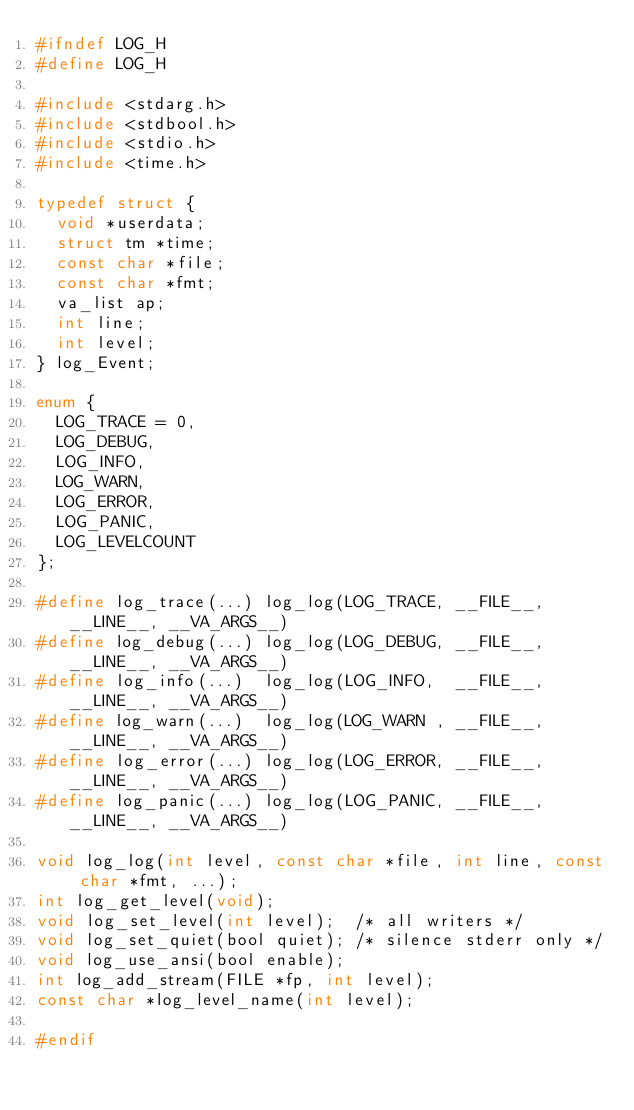Convert code to text. <code><loc_0><loc_0><loc_500><loc_500><_C_>#ifndef LOG_H
#define LOG_H

#include <stdarg.h>
#include <stdbool.h>
#include <stdio.h>
#include <time.h>

typedef struct {
  void *userdata;
  struct tm *time;
  const char *file;
  const char *fmt;
  va_list ap;
  int line;
  int level;
} log_Event;

enum {
  LOG_TRACE = 0,
  LOG_DEBUG,
  LOG_INFO,
  LOG_WARN,
  LOG_ERROR,
  LOG_PANIC,
  LOG_LEVELCOUNT
};

#define log_trace(...) log_log(LOG_TRACE, __FILE__, __LINE__, __VA_ARGS__)
#define log_debug(...) log_log(LOG_DEBUG, __FILE__, __LINE__, __VA_ARGS__)
#define log_info(...)  log_log(LOG_INFO,  __FILE__, __LINE__, __VA_ARGS__)
#define log_warn(...)  log_log(LOG_WARN , __FILE__, __LINE__, __VA_ARGS__)
#define log_error(...) log_log(LOG_ERROR, __FILE__, __LINE__, __VA_ARGS__)
#define log_panic(...) log_log(LOG_PANIC, __FILE__, __LINE__, __VA_ARGS__)

void log_log(int level, const char *file, int line, const char *fmt, ...);
int log_get_level(void);
void log_set_level(int level);  /* all writers */
void log_set_quiet(bool quiet); /* silence stderr only */
void log_use_ansi(bool enable);
int log_add_stream(FILE *fp, int level);
const char *log_level_name(int level);

#endif
</code> 